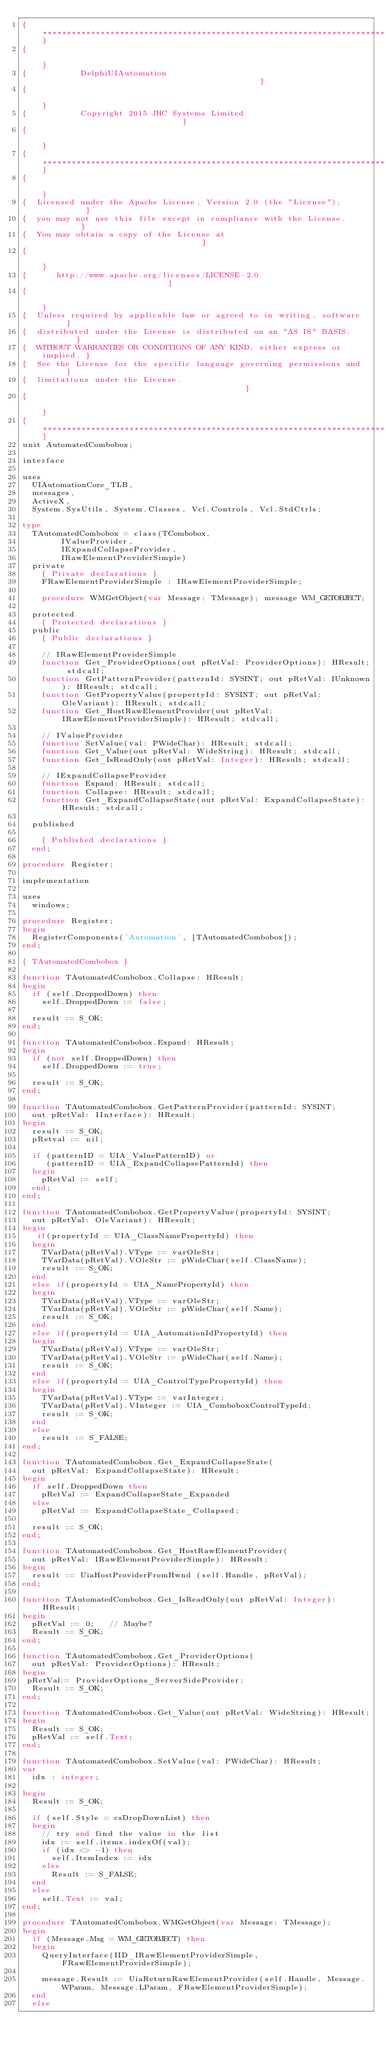Convert code to text. <code><loc_0><loc_0><loc_500><loc_500><_Pascal_>{***************************************************************************}
{                                                                           }
{           DelphiUIAutomation                                              }
{                                                                           }
{           Copyright 2015 JHC Systems Limited                              }
{                                                                           }
{***************************************************************************}
{                                                                           }
{  Licensed under the Apache License, Version 2.0 (the "License");          }
{  you may not use this file except in compliance with the License.         }
{  You may obtain a copy of the License at                                  }
{                                                                           }
{      http://www.apache.org/licenses/LICENSE-2.0                           }
{                                                                           }
{  Unless required by applicable law or agreed to in writing, software      }
{  distributed under the License is distributed on an "AS IS" BASIS,        }
{  WITHOUT WARRANTIES OR CONDITIONS OF ANY KIND, either express or implied. }
{  See the License for the specific language governing permissions and      }
{  limitations under the License.                                           }
{                                                                           }
{***************************************************************************}
unit AutomatedCombobox;

interface

uses
  UIAutomationCore_TLB,
  messages,
  ActiveX,
  System.SysUtils, System.Classes, Vcl.Controls, Vcl.StdCtrls;

type
  TAutomatedCombobox = class(TCombobox,
        IValueProvider,
        IExpandCollapseProvider,
        IRawElementProviderSimple)
  private
    { Private declarations }
    FRawElementProviderSimple : IRawElementProviderSimple;

    procedure WMGetObject(var Message: TMessage); message WM_GETOBJECT;

  protected
    { Protected declarations }
  public
    { Public declarations }

    // IRawElementProviderSimple
    function Get_ProviderOptions(out pRetVal: ProviderOptions): HResult; stdcall;
    function GetPatternProvider(patternId: SYSINT; out pRetVal: IUnknown): HResult; stdcall;
    function GetPropertyValue(propertyId: SYSINT; out pRetVal: OleVariant): HResult; stdcall;
    function Get_HostRawElementProvider(out pRetVal: IRawElementProviderSimple): HResult; stdcall;

    // IValueProvider
    function SetValue(val: PWideChar): HResult; stdcall;
    function Get_Value(out pRetVal: WideString): HResult; stdcall;
    function Get_IsReadOnly(out pRetVal: Integer): HResult; stdcall;

    // IExpandCollapseProvider
    function Expand: HResult; stdcall;
    function Collapse: HResult; stdcall;
    function Get_ExpandCollapseState(out pRetVal: ExpandCollapseState): HResult; stdcall;

  published

    { Published declarations }
  end;

procedure Register;

implementation

uses
  windows;

procedure Register;
begin
  RegisterComponents('Automation', [TAutomatedCombobox]);
end;

{ TAutomatedCombobox }

function TAutomatedCombobox.Collapse: HResult;
begin
  if (self.DroppedDown) then
    self.DroppedDown := false;

  result := S_OK;
end;

function TAutomatedCombobox.Expand: HResult;
begin
  if (not self.DroppedDown) then
    self.DroppedDown := true;

  result := S_OK;
end;

function TAutomatedCombobox.GetPatternProvider(patternId: SYSINT;
  out pRetVal: IInterface): HResult;
begin
  result := S_OK;
  pRetval := nil;

  if (patternID = UIA_ValuePatternID) or
     (patternID = UIA_ExpandCollapsePatternId) then
  begin
    pRetVal := self;
  end;
end;

function TAutomatedCombobox.GetPropertyValue(propertyId: SYSINT;
  out pRetVal: OleVariant): HResult;
begin
   if(propertyId = UIA_ClassNamePropertyId) then
  begin
    TVarData(pRetVal).VType := varOleStr;
    TVarData(pRetVal).VOleStr := pWideChar(self.ClassName);
    result := S_OK;
  end
  else if(propertyId = UIA_NamePropertyId) then
  begin
    TVarData(pRetVal).VType := varOleStr;
    TVarData(pRetVal).VOleStr := pWideChar(self.Name);
    result := S_OK;
  end
  else if(propertyId = UIA_AutomationIdPropertyId) then
  begin
    TVarData(pRetVal).VType := varOleStr;
    TVarData(pRetVal).VOleStr := pWideChar(self.Name);
    result := S_OK;
  end
  else if(propertyId = UIA_ControlTypePropertyId) then
  begin
    TVarData(pRetVal).VType := varInteger;
    TVarData(pRetVal).VInteger := UIA_ComboboxControlTypeId;
    result := S_OK;
  end
  else
    result := S_FALSE;
end;

function TAutomatedCombobox.Get_ExpandCollapseState(
  out pRetVal: ExpandCollapseState): HResult;
begin
  if self.DroppedDown then
    pRetVal := ExpandCollapseState_Expanded
  else
    pRetVal := ExpandCollapseState_Collapsed;

  result := S_OK;
end;

function TAutomatedCombobox.Get_HostRawElementProvider(
  out pRetVal: IRawElementProviderSimple): HResult;
begin
  result := UiaHostProviderFromHwnd (self.Handle, pRetVal);
end;

function TAutomatedCombobox.Get_IsReadOnly(out pRetVal: Integer): HResult;
begin
  pRetVal := 0;   // Maybe?
  Result := S_OK;
end;

function TAutomatedCombobox.Get_ProviderOptions(
  out pRetVal: ProviderOptions): HResult;
begin
 pRetVal:= ProviderOptions_ServerSideProvider;
  Result := S_OK;
end;

function TAutomatedCombobox.Get_Value(out pRetVal: WideString): HResult;
begin
  Result := S_OK;
  pRetVal := self.Text;
end;

function TAutomatedCombobox.SetValue(val: PWideChar): HResult;
var
  idx : integer;
  
begin
  Result := S_OK;

  if (self.Style = csDropDownList) then
  begin
    // try and find the value in the list  
    idx := self.items.indexOf(val);   
    if (idx <> -1) then    
      self.ItemIndex := idx
    else
      Result := S_FALSE;    
  end
  else  
    self.Text := val;    
end;

procedure TAutomatedCombobox.WMGetObject(var Message: TMessage);
begin
  if (Message.Msg = WM_GETOBJECT) then
  begin
    QueryInterface(IID_IRawElementProviderSimple, FRawElementProviderSimple);

    message.Result := UiaReturnRawElementProvider(self.Handle, Message.WParam, Message.LParam, FRawElementProviderSimple);
  end
  else</code> 